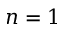<formula> <loc_0><loc_0><loc_500><loc_500>n = 1</formula> 